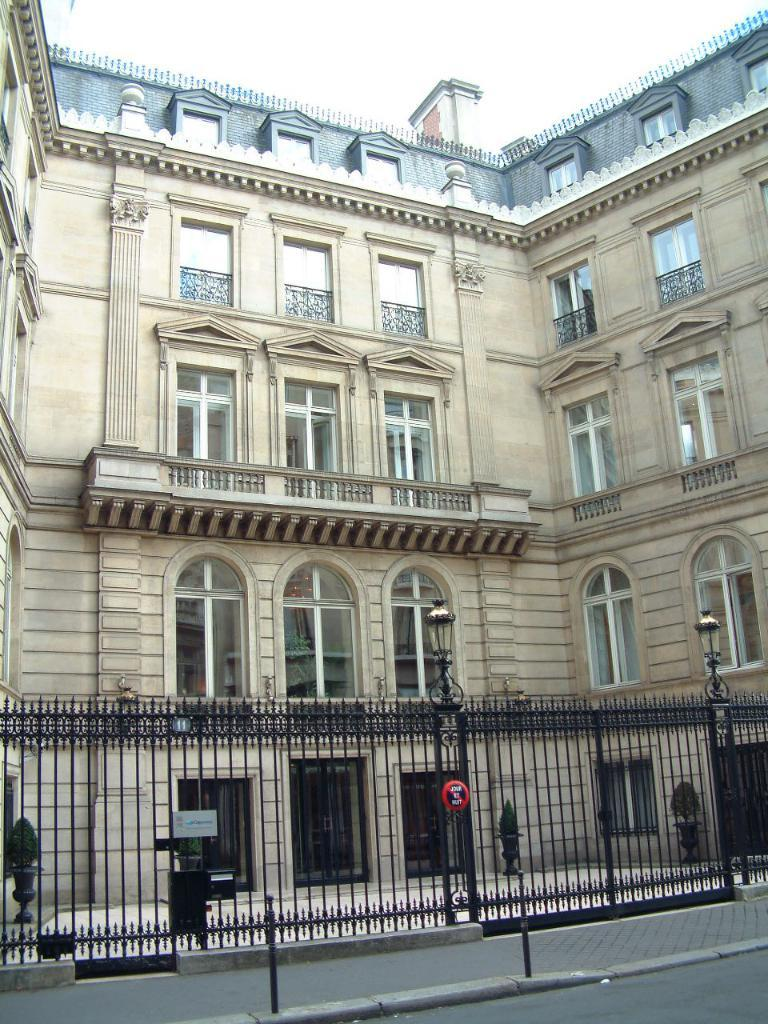What type of structure is present in the image? There is a building in the image. What feature can be seen on the building? The building has windows. What additional object is present in the image? There is an iron grill in the image. What can be seen in the background of the image? The sky is visible in the image. How many pets are visible in the image? There are no pets present in the image. What type of spacecraft can be seen in the image? There is no spacecraft present in the image. 